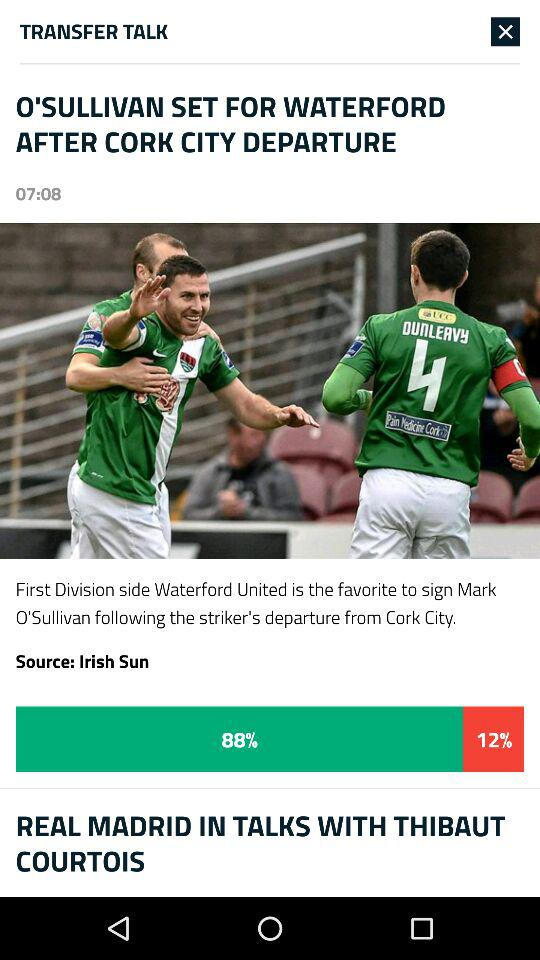At what time was "O'SULLIVAN SET FOR WATERFORD AFTER CORK CITY DEPARTURE" posted? "O'SULLIVAN SET FOR WATERFORD AFTER CORK CITY DEPARTURE" was posted at 07:08. 